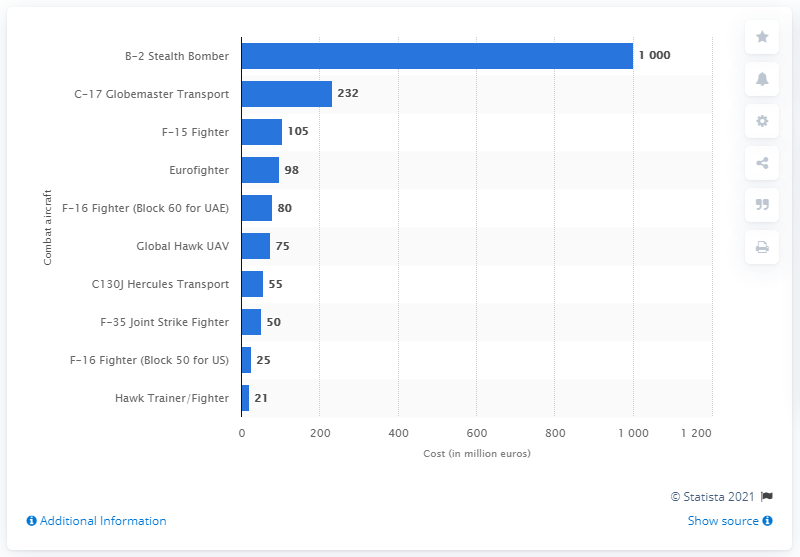Point out several critical features in this image. BAE Systems' Hawk trainer/fighter cost 21.. 